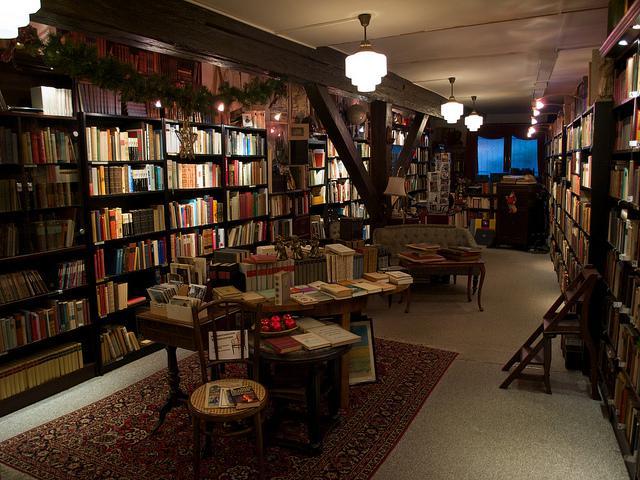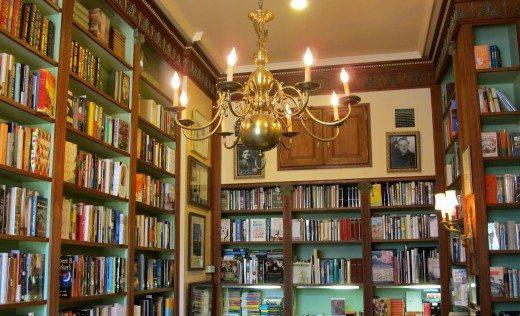The first image is the image on the left, the second image is the image on the right. Assess this claim about the two images: "Ceiling lights are visible in both images.". Correct or not? Answer yes or no. Yes. The first image is the image on the left, the second image is the image on the right. Given the left and right images, does the statement "Seats are available in the reading area in the image on the right." hold true? Answer yes or no. No. 